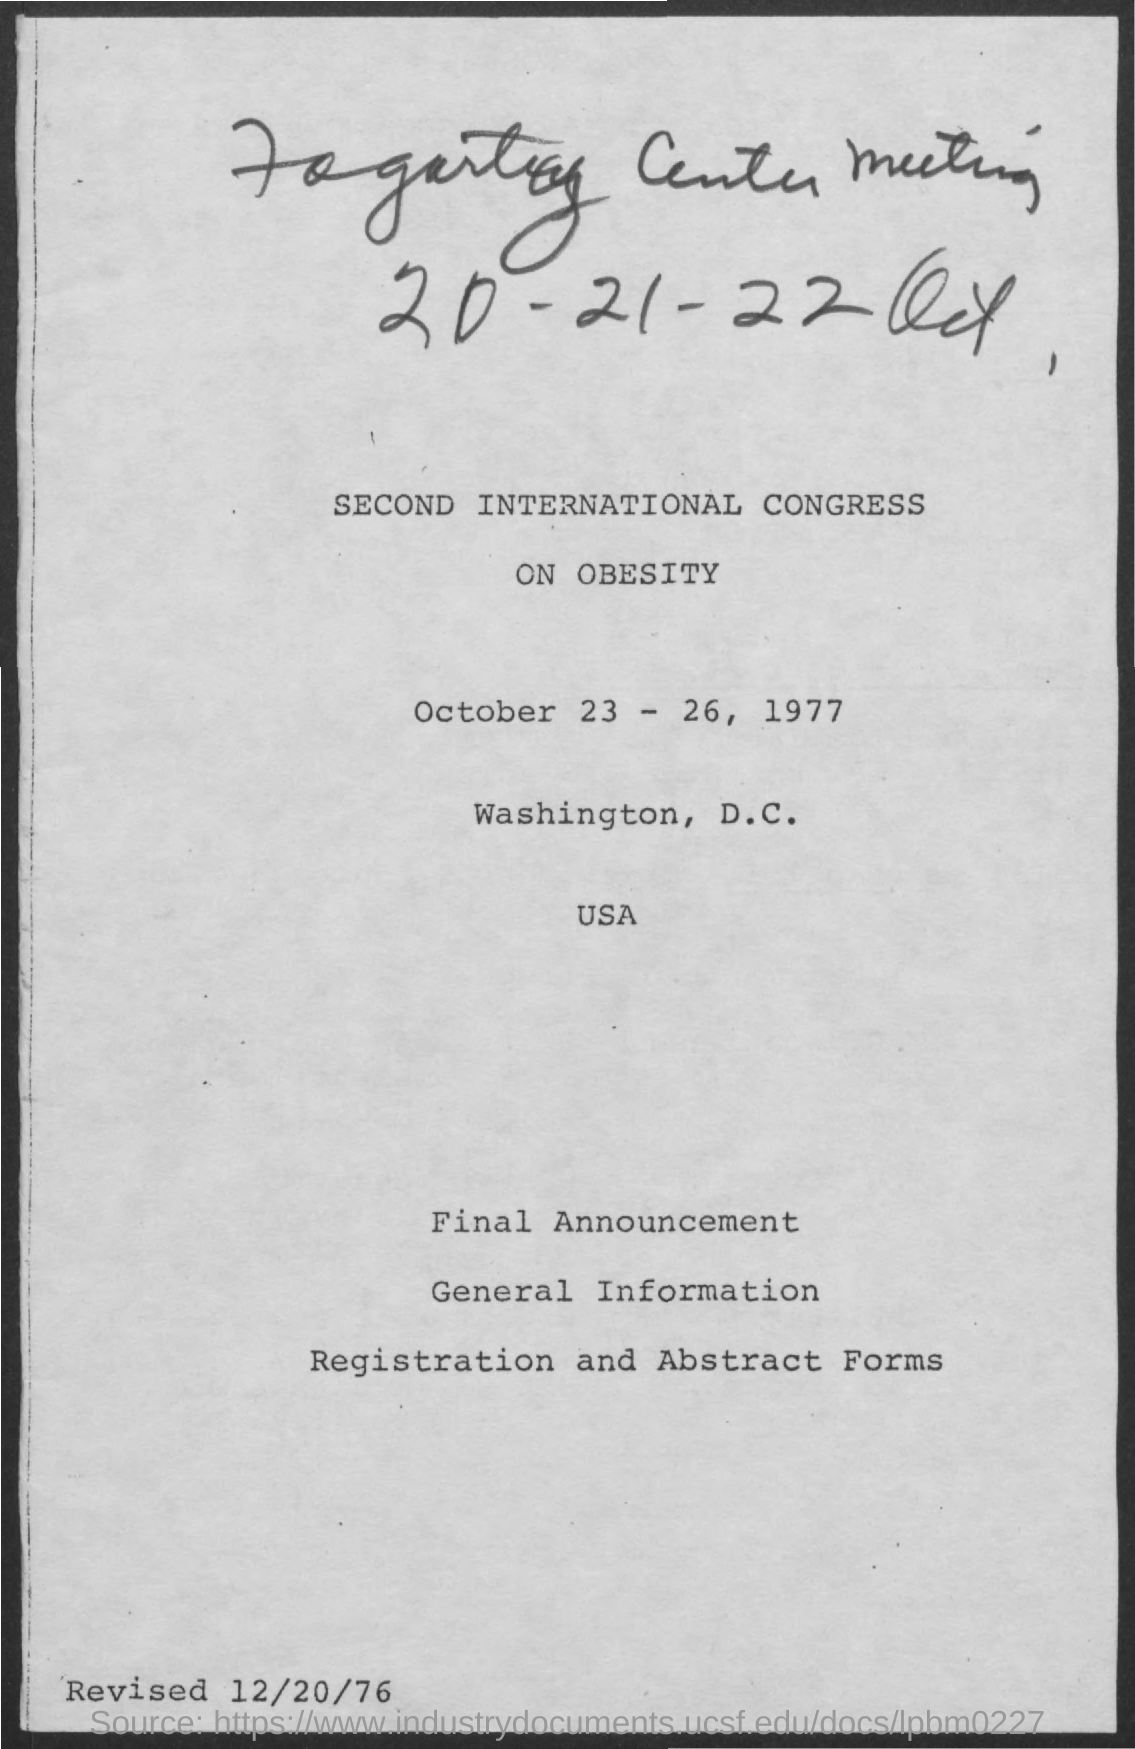Which place the international congress conducted?
Your response must be concise. WASHINGTON, D.C. 